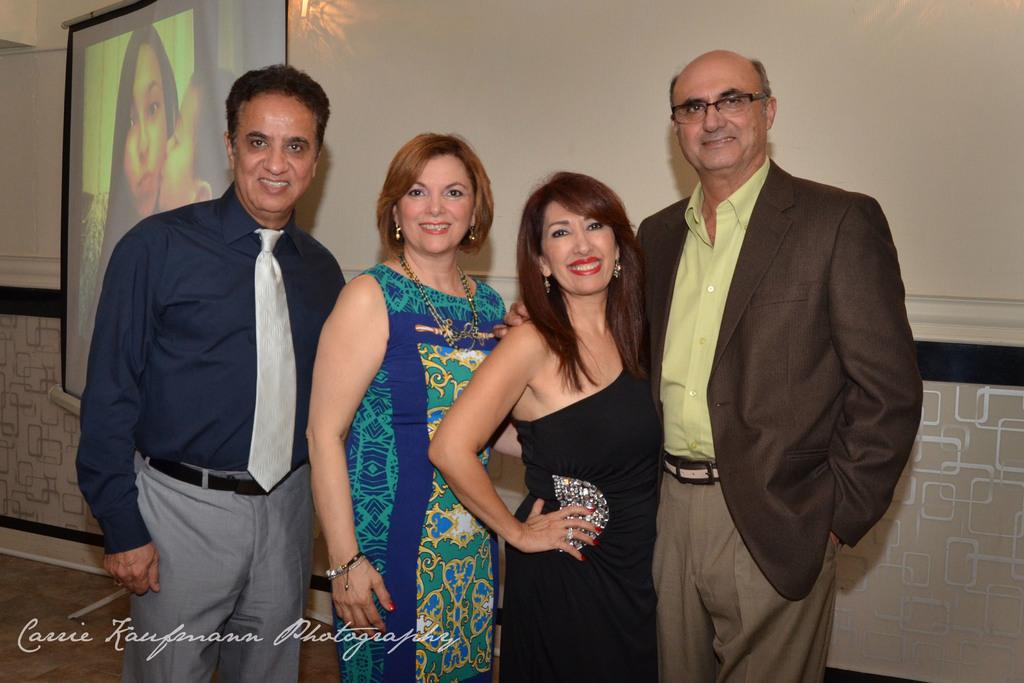How many people are present in the image? There are four persons in the image. What are the persons doing in the image? The persons are standing on the floor and smiling. What can be seen in the background of the image? There is a screen and a wall in the background of the image. What type of bikes are being used by the persons in the image? There are no bikes present in the image; the persons are standing on the floor. What is the source of coal in the image? There is no coal present in the image. What type of copper objects can be seen in the image? There are no copper objects present in the image. 